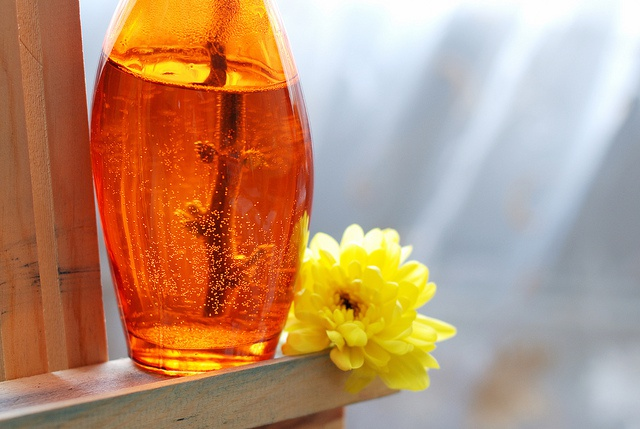Describe the objects in this image and their specific colors. I can see a vase in gray, red, brown, and orange tones in this image. 